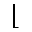<formula> <loc_0><loc_0><loc_500><loc_500>\lfloor</formula> 